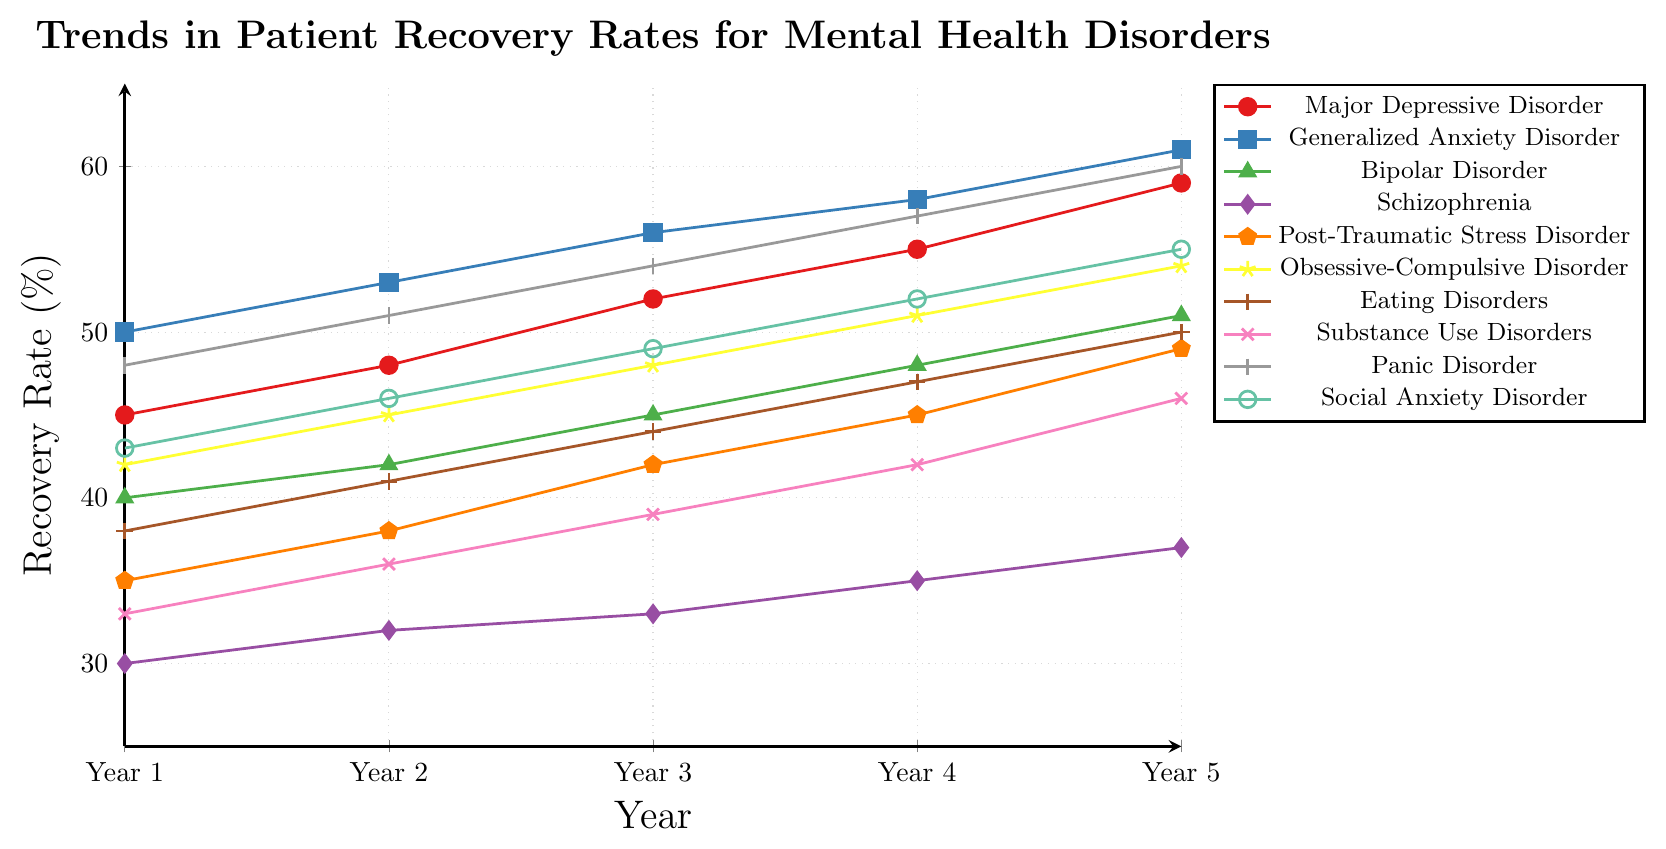Which disorder shows the highest recovery rate in Year 5? The recovery rates in Year 5 for all disorders are given. Compare these values to find the highest one. Generalized Anxiety Disorder has a recovery rate of 61%, which is the highest among all.
Answer: Generalized Anxiety Disorder How does the recovery rate trend for Schizophrenia over the 5 years? Observe the recovery rate of Schizophrenia from Year 1 to Year 5: 30%, 32%, 33%, 35%, and 37%. The trend shows a gradual increase.
Answer: Gradual increase Which disorders have a recovery rate of 50% in Year 1, if any? Look at the recovery rates for each disorder in Year 1. Only Generalized Anxiety Disorder has a recovery rate of 50% in Year 1.
Answer: Generalized Anxiety Disorder What is the average recovery rate for Panic Disorder over the 5 years? The recovery rates for Panic Disorder over the 5 years are 48%, 51%, 54%, 57%, and 60%. Adding these values gives a total of 270. Dividing by 5, the average recovery rate is 270/5 = 54%.
Answer: 54% Which three disorders have the fastest-growing recovery rates? Observe the increase in recovery rates over the 5 years for each disorder. Generalized Anxiety Disorder (11%), Major Depressive Disorder (14%), Panic Disorder (12%), and, Substance Use Disorders (13%) show the fastest growth. The top three are Major Depressive Disorder, Panic Disorder, and Substance Use Disorders.
Answer: Major Depressive Disorder, Panic Disorder, Substance Use Disorders Compare the recovery rate of Bipolar Disorder in Year 2 and Year 4. Which year had a higher rate and by how much? The recovery rates for Bipolar Disorder in Year 2 and Year 4 are 42% and 48%, respectively. Year 4 had a higher rate. The difference is 48% - 42% = 6%.
Answer: Year 4, 6% What is the difference in recovery rates between Substance Use Disorders and Social Anxiety Disorder in Year 3? The recovery rates in Year 3 for Substance Use Disorders is 39% and for Social Anxiety Disorder is 49%. The difference is 49% - 39% = 10%.
Answer: 10% Which disorder had the lowest initial recovery rate, and what was it? Compare the recovery rates of all disorders in Year 1. Schizophrenia had the lowest initial rate at 30%.
Answer: Schizophrenia, 30% Identify the disorder with a yellow marker. What is its recovery rate in Year 4? The disorder with a yellow marker is Obsessive-Compulsive Disorder. Its recovery rate in Year 4 is 51%.
Answer: Obsessive-Compulsive Disorder, 51% 